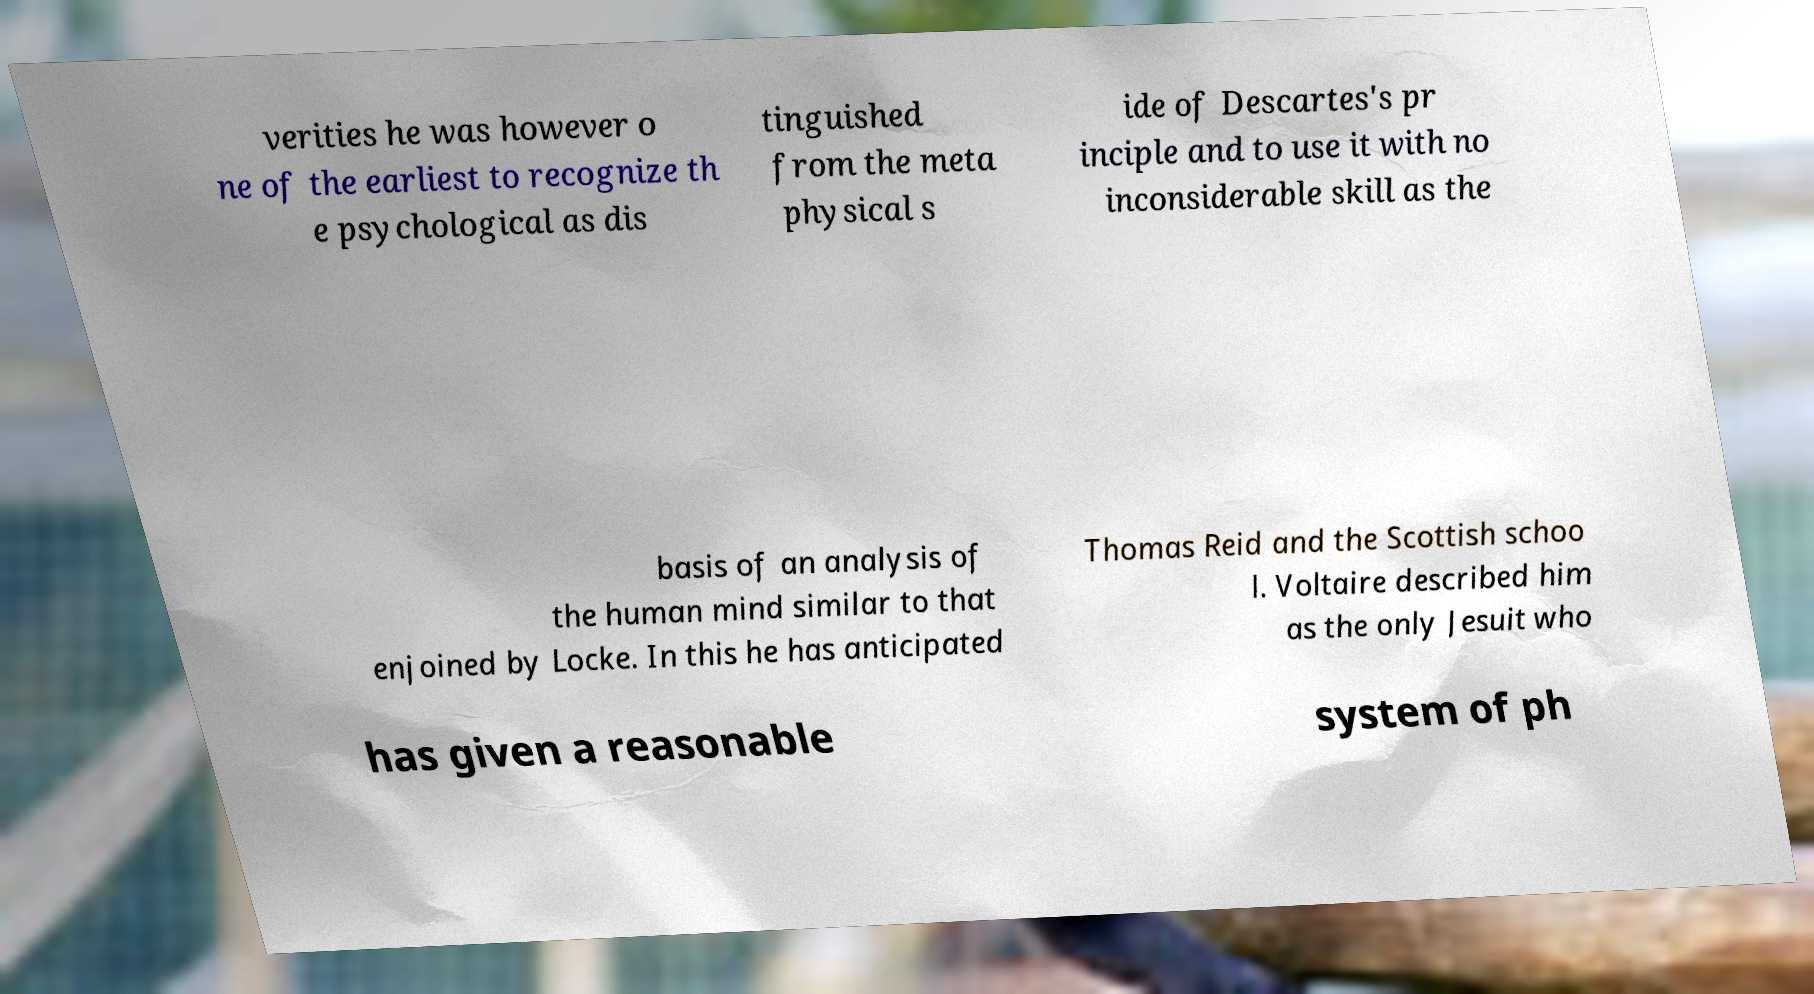Please identify and transcribe the text found in this image. verities he was however o ne of the earliest to recognize th e psychological as dis tinguished from the meta physical s ide of Descartes's pr inciple and to use it with no inconsiderable skill as the basis of an analysis of the human mind similar to that enjoined by Locke. In this he has anticipated Thomas Reid and the Scottish schoo l. Voltaire described him as the only Jesuit who has given a reasonable system of ph 